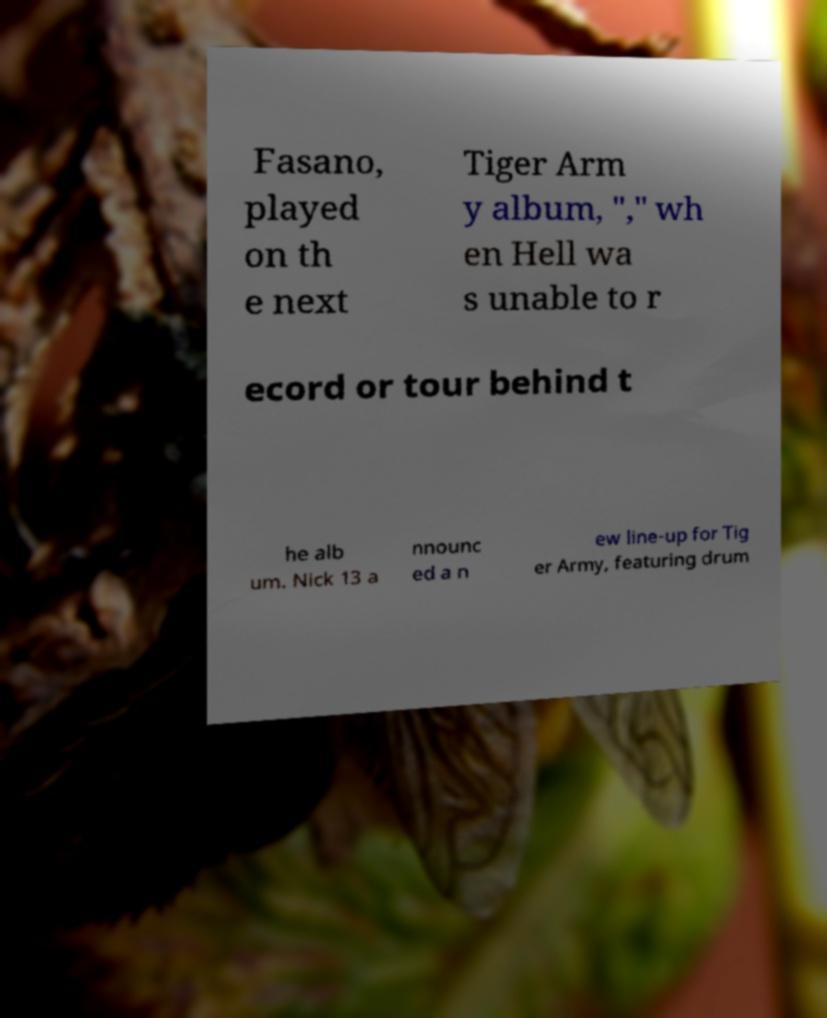I need the written content from this picture converted into text. Can you do that? Fasano, played on th e next Tiger Arm y album, "," wh en Hell wa s unable to r ecord or tour behind t he alb um. Nick 13 a nnounc ed a n ew line-up for Tig er Army, featuring drum 